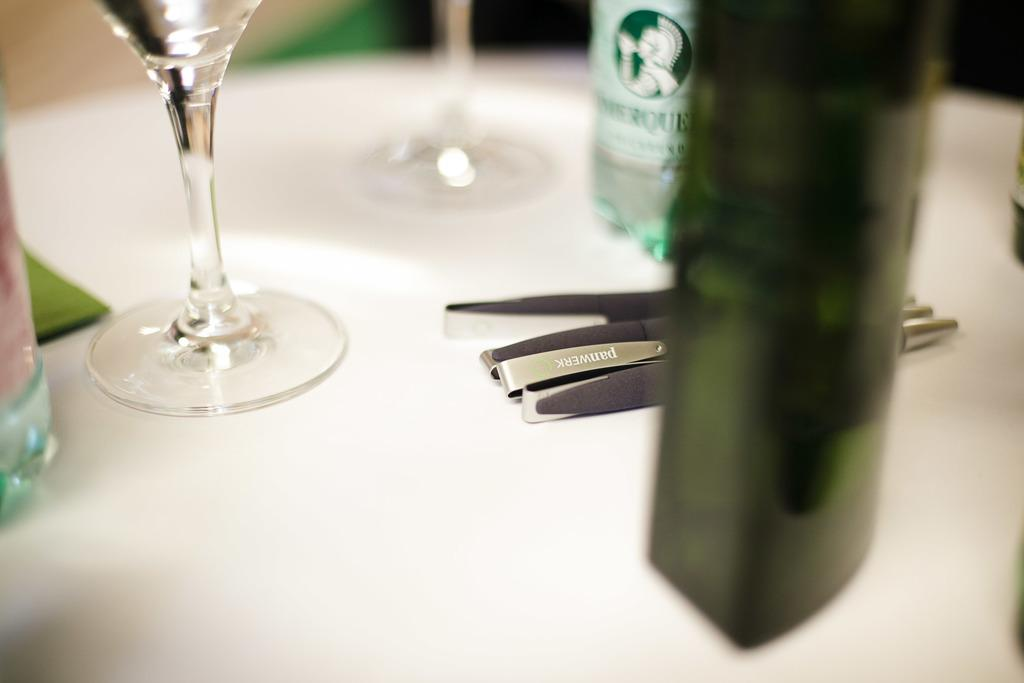What is one of the objects placed on the table in the image? There is a glass in the image. What else can be seen on the table in the image? There are bottles and pens in the image. Can you describe the arrangement of the objects on the table? The glass, bottles, and pens are placed on a table. What is the opinion of the grandmother about the ship in the image? There is no grandmother or ship present in the image, so it is not possible to answer that question. 